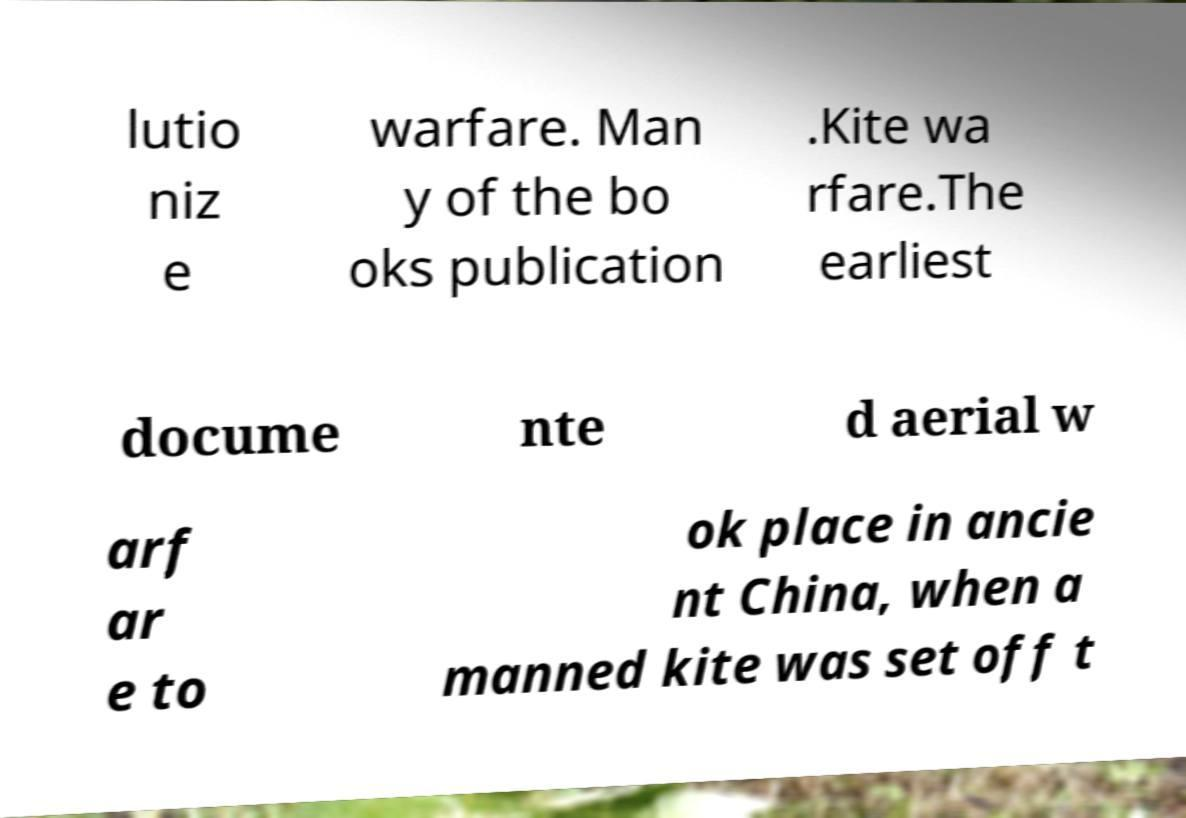Can you accurately transcribe the text from the provided image for me? lutio niz e warfare. Man y of the bo oks publication .Kite wa rfare.The earliest docume nte d aerial w arf ar e to ok place in ancie nt China, when a manned kite was set off t 